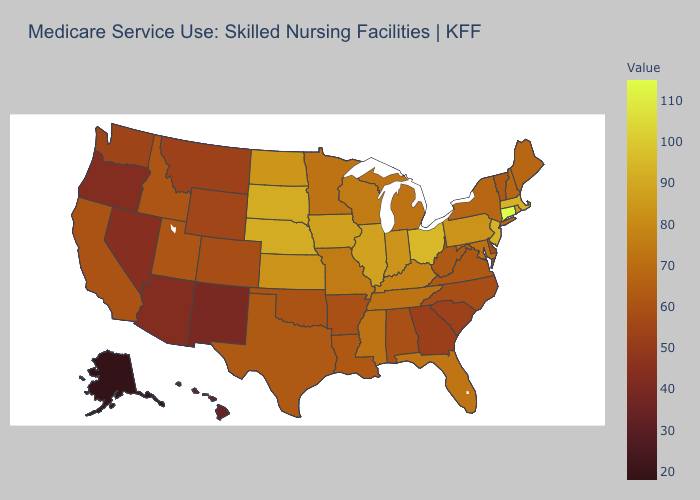Does Oregon have the lowest value in the West?
Answer briefly. No. Does Connecticut have the highest value in the USA?
Concise answer only. Yes. Does Alaska have the lowest value in the USA?
Give a very brief answer. Yes. Does New York have a lower value than Montana?
Answer briefly. No. Does Missouri have a higher value than Louisiana?
Quick response, please. Yes. Does Colorado have a lower value than Florida?
Concise answer only. Yes. Among the states that border New Hampshire , does Vermont have the lowest value?
Give a very brief answer. Yes. Which states have the lowest value in the USA?
Concise answer only. Alaska. 